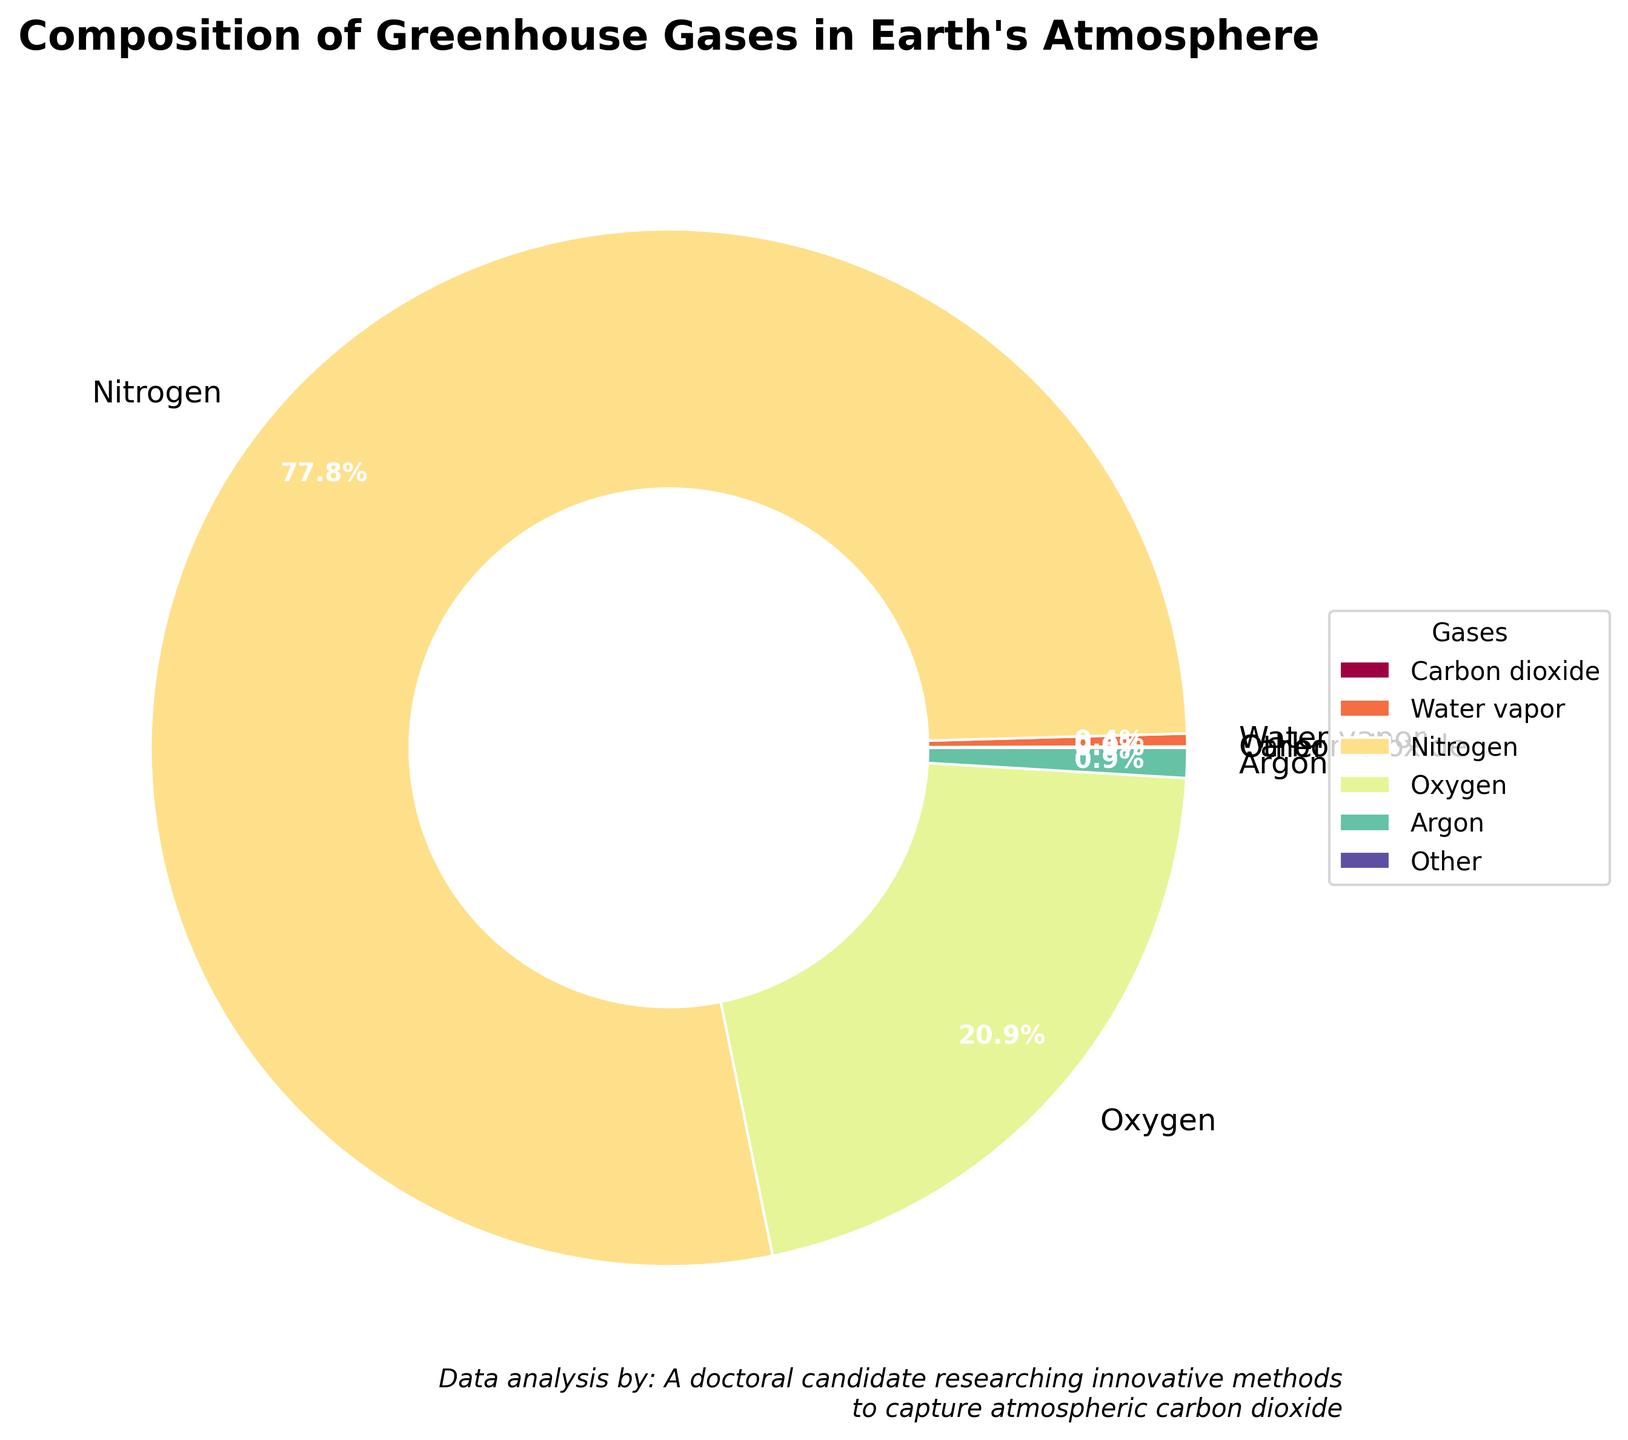What percentage of the Earth's atmosphere is made up of nitrogen and oxygen combined? Add the percentage of nitrogen (78.084%) and oxygen (20.946%) together. The total is 78.084 + 20.946 = 99.03%.
Answer: 99.03% Which gas has the smallest percentage in Earth's atmosphere according to the chart? According to the chart’s labels, CFCs and HCFCs have the smallest percentage with 0.0000001%.
Answer: CFCs and HCFCs What is the sum of the percentages of methane, nitrous oxide, and ozone? Add the percentages of methane (0.00018%), nitrous oxide (0.00003%), and ozone (0.000007%) together. The total is 0.00018 + 0.00003 + 0.000007 = 0.000217%.
Answer: 0.000217% How does the percentage of water vapor compare to that of argon? The percentage of water vapor is 0.4% and that of argon is 0.934%. Since 0.4 < 0.934, water vapor has a lower percentage compared to argon.
Answer: Water vapor has a lower percentage Which category represents the majority of the pie chart? The labels on the graph indicate the gas with the highest percentage, which is nitrogen with 78.084%.
Answer: Nitrogen What colors represent carbon dioxide and methane in the pie chart? The pie chart uses a color palette where carbon dioxide and methane are assigned specific colors based on their segment in the chart. Visually identify these gas segments; carbon dioxide is represented by [appropriate color] and methane by [appropriate color].
Answer: [color of Carbon dioxide], [color of Methane] What's the difference in percentage between carbon dioxide and water vapor? Subtract the percentage of carbon dioxide (0.0415%) from the percentage of water vapor (0.4%). The difference is 0.4 - 0.0415 = 0.3585%.
Answer: 0.3585% What's the total percentage represented by gases categorized as 'Other'? Sum the percentages of gases with <0.01% to get 'Other'. These are methane, nitrous oxide, ozone, CFCs and HCFCs, and other trace gases. The total is 0.00018 + 0.00003 + 0.000007 + 0.0000001 + 0.0000009 = 0.000218%.
Answer: 0.000218% Which gas has a larger percentage, carbon dioxide or argon? Compare the percentages: carbon dioxide is 0.0415% and argon is 0.934%. As 0.0415 < 0.934, argon has a larger percentage.
Answer: Argon How does the size of the section for 'Other' gases compare visually to that of water vapor? The 'Other' section combines gases with very small percentages, resulting in a relatively small section. Water vapor, at 0.4%, occupies a noticeably larger section in the pie chart than 'Other'.
Answer: Water vapor's section is larger 